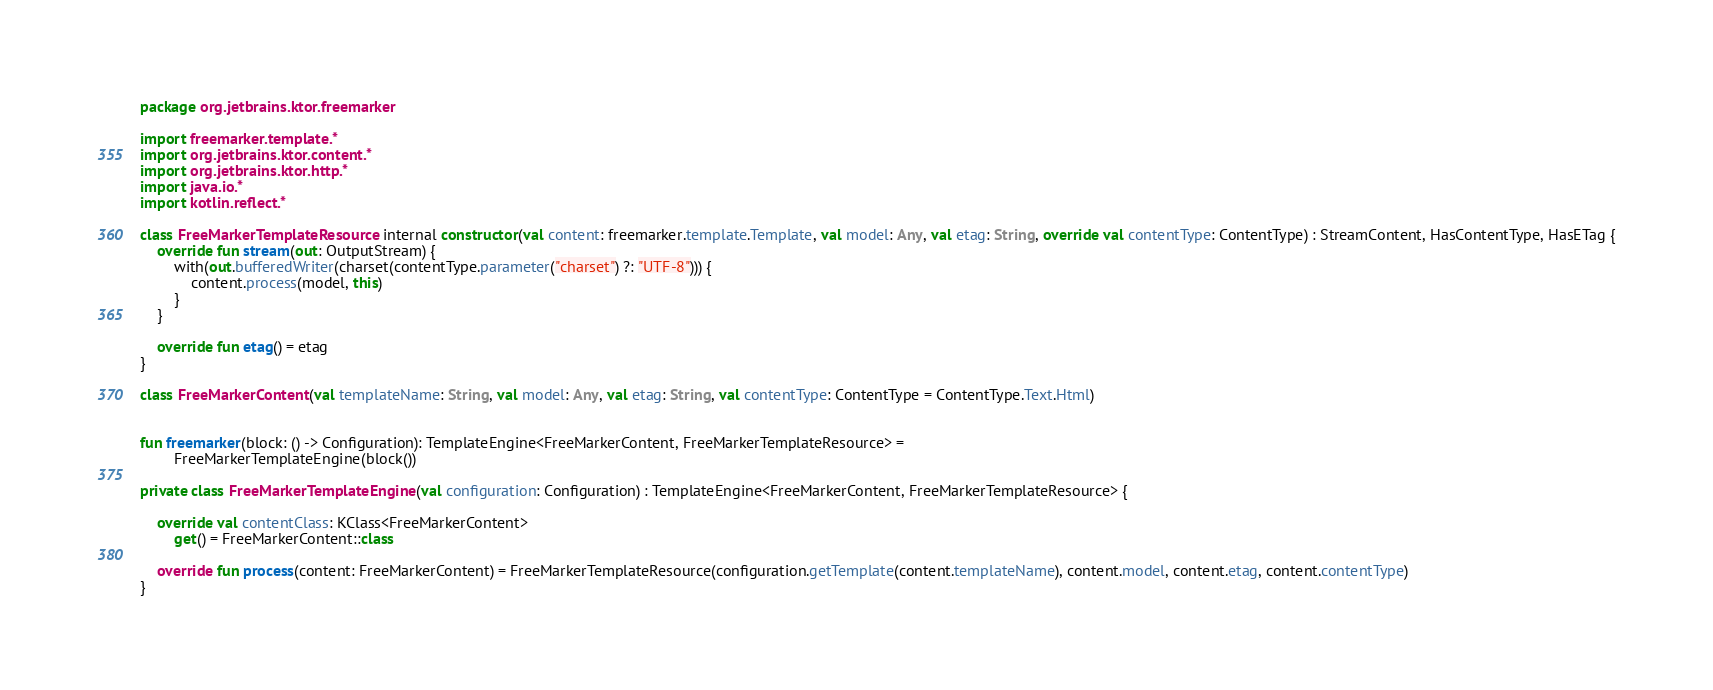<code> <loc_0><loc_0><loc_500><loc_500><_Kotlin_>package org.jetbrains.ktor.freemarker

import freemarker.template.*
import org.jetbrains.ktor.content.*
import org.jetbrains.ktor.http.*
import java.io.*
import kotlin.reflect.*

class FreeMarkerTemplateResource internal constructor(val content: freemarker.template.Template, val model: Any, val etag: String, override val contentType: ContentType) : StreamContent, HasContentType, HasETag {
    override fun stream(out: OutputStream) {
        with(out.bufferedWriter(charset(contentType.parameter("charset") ?: "UTF-8"))) {
            content.process(model, this)
        }
    }

    override fun etag() = etag
}

class FreeMarkerContent(val templateName: String, val model: Any, val etag: String, val contentType: ContentType = ContentType.Text.Html)


fun freemarker(block: () -> Configuration): TemplateEngine<FreeMarkerContent, FreeMarkerTemplateResource> =
        FreeMarkerTemplateEngine(block())

private class FreeMarkerTemplateEngine(val configuration: Configuration) : TemplateEngine<FreeMarkerContent, FreeMarkerTemplateResource> {

    override val contentClass: KClass<FreeMarkerContent>
        get() = FreeMarkerContent::class

    override fun process(content: FreeMarkerContent) = FreeMarkerTemplateResource(configuration.getTemplate(content.templateName), content.model, content.etag, content.contentType)
}
</code> 